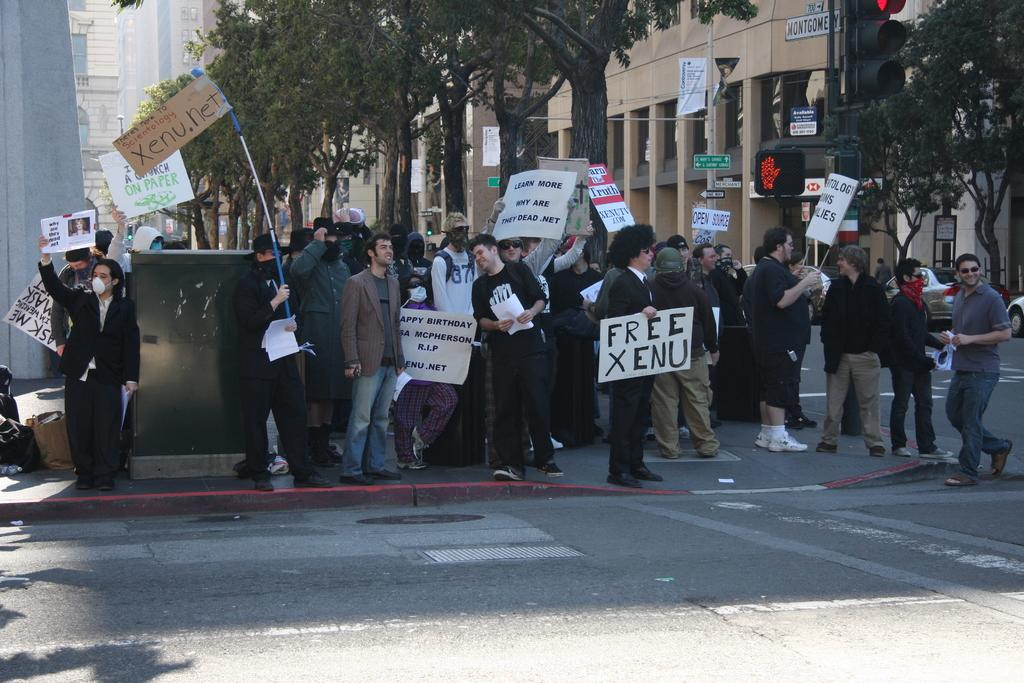What are the people in the image doing? The people in the image are standing and holding boards. What are the people wearing on their faces? The people are wearing masks. What can be seen in the distance behind the people? There are buildings visible in the background of the image. What type of bun is being used to attack the buildings in the image? There is no bun or attack present in the image; the people are holding boards and wearing masks. 